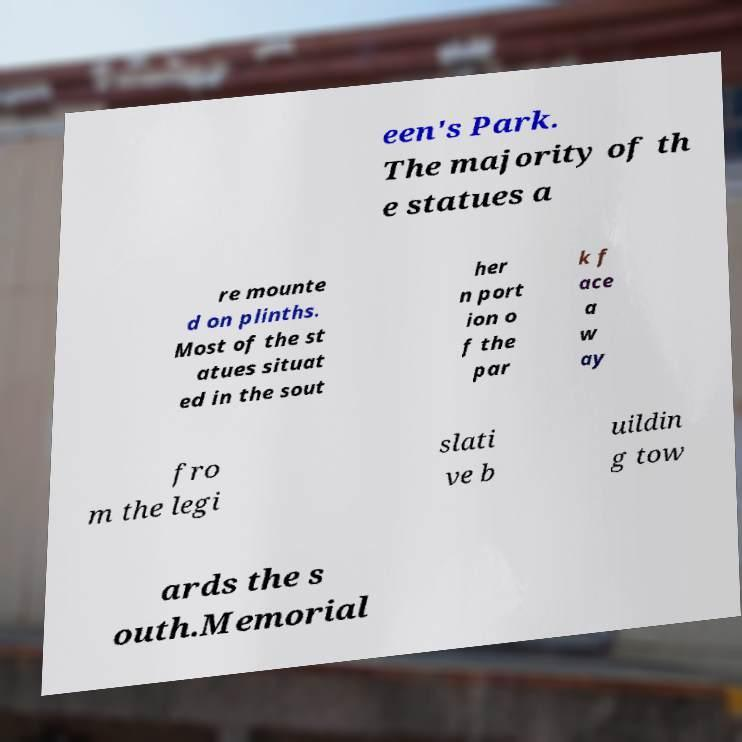Can you read and provide the text displayed in the image?This photo seems to have some interesting text. Can you extract and type it out for me? een's Park. The majority of th e statues a re mounte d on plinths. Most of the st atues situat ed in the sout her n port ion o f the par k f ace a w ay fro m the legi slati ve b uildin g tow ards the s outh.Memorial 